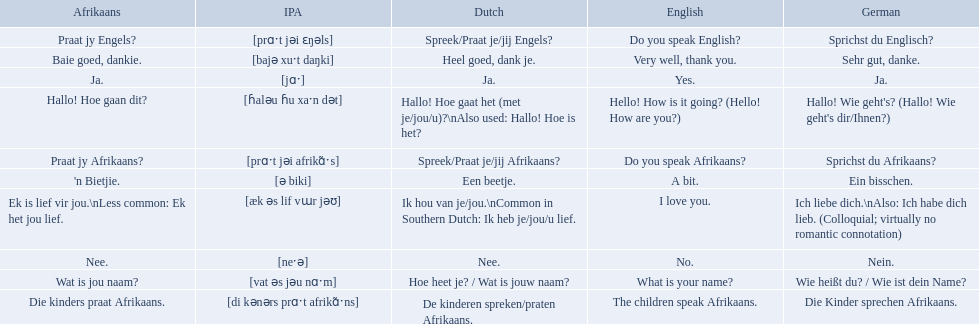What are the listed afrikaans phrases? Hallo! Hoe gaan dit?, Baie goed, dankie., Praat jy Afrikaans?, Praat jy Engels?, Ja., Nee., 'n Bietjie., Wat is jou naam?, Die kinders praat Afrikaans., Ek is lief vir jou.\nLess common: Ek het jou lief. Which is die kinders praat afrikaans? Die kinders praat Afrikaans. What is its german translation? Die Kinder sprechen Afrikaans. 